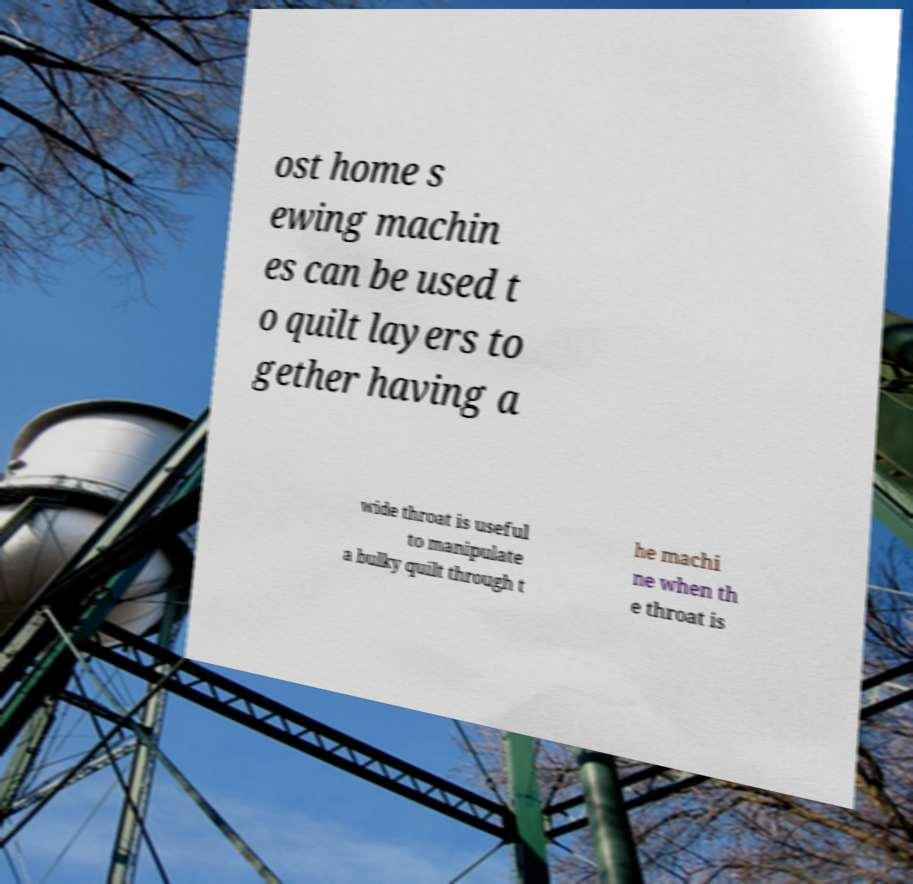What messages or text are displayed in this image? I need them in a readable, typed format. ost home s ewing machin es can be used t o quilt layers to gether having a wide throat is useful to manipulate a bulky quilt through t he machi ne when th e throat is 